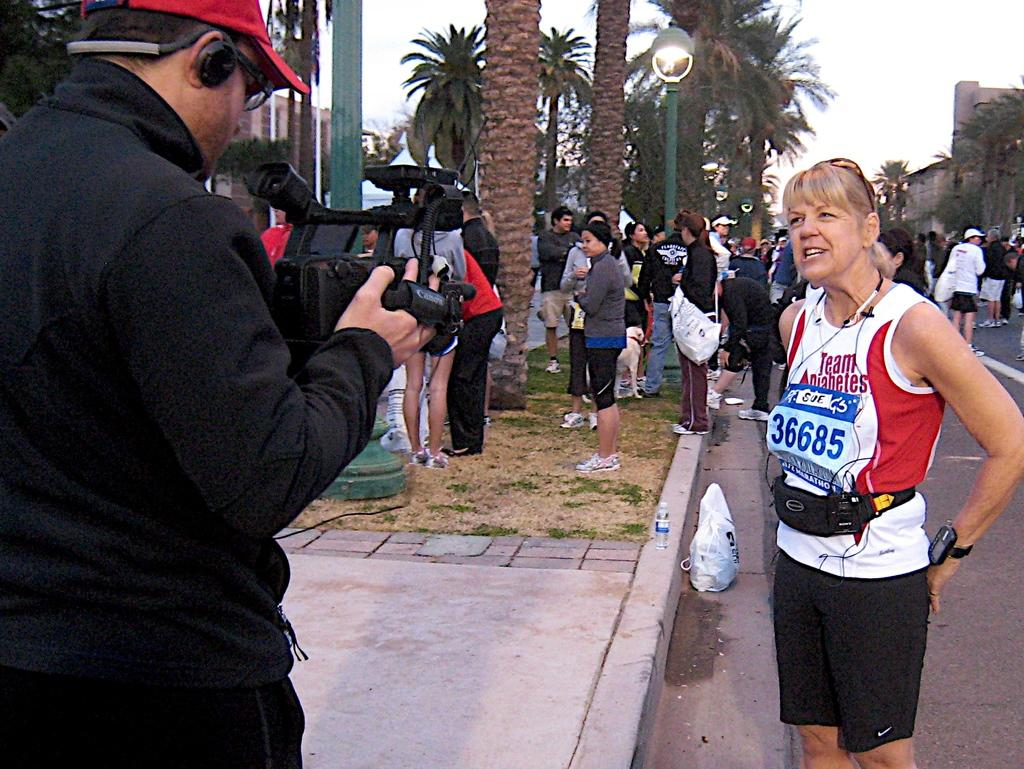Provide a one-sentence caption for the provided image. Racer 36685 stands in the street having her picture taken. 